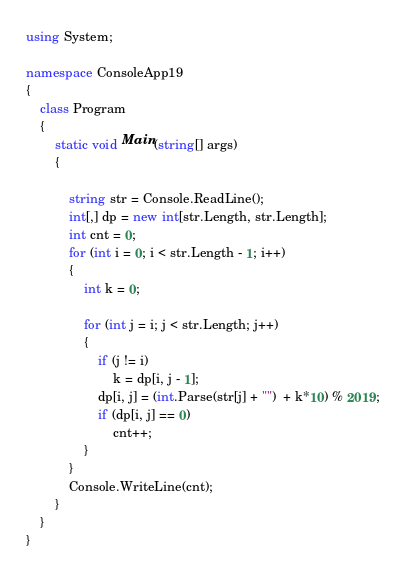Convert code to text. <code><loc_0><loc_0><loc_500><loc_500><_C#_>using System;

namespace ConsoleApp19
{
    class Program
    {
        static void Main(string[] args)
        {

            string str = Console.ReadLine();
            int[,] dp = new int[str.Length, str.Length];
            int cnt = 0;
            for (int i = 0; i < str.Length - 1; i++)
            {
                int k = 0;

                for (int j = i; j < str.Length; j++)
                {
                    if (j != i)
                        k = dp[i, j - 1];
                    dp[i, j] = (int.Parse(str[j] + "")  + k*10) % 2019;
                    if (dp[i, j] == 0)
                        cnt++;
                }
            }
            Console.WriteLine(cnt);
        }
    }
}
</code> 